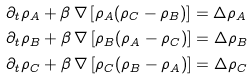<formula> <loc_0><loc_0><loc_500><loc_500>& \partial _ { t } \rho _ { A } + \beta \, \nabla \left [ \rho _ { A } ( \rho _ { C } - \rho _ { B } ) \right ] = \Delta \rho _ { A } \\ & \partial _ { t } \rho _ { B } + \beta \, \nabla \left [ \rho _ { B } ( \rho _ { A } - \rho _ { C } ) \right ] = \Delta \rho _ { B } \\ & \partial _ { t } \rho _ { C } + \beta \, \nabla \left [ \rho _ { C } ( \rho _ { B } - \rho _ { A } ) \right ] = \Delta \rho _ { C }</formula> 